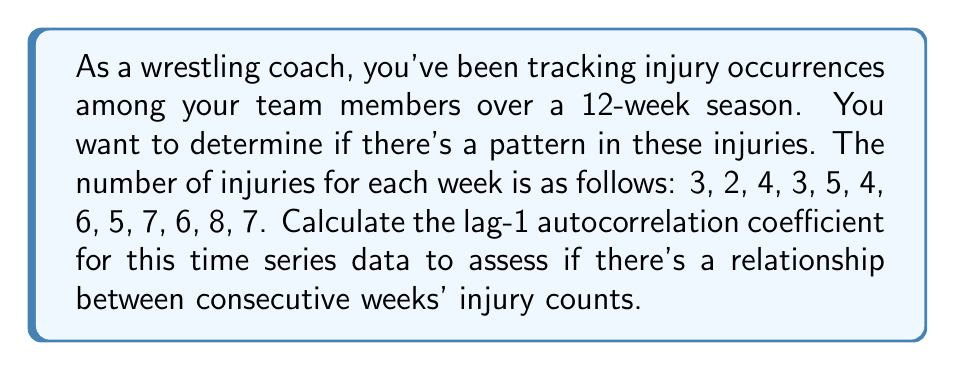Can you answer this question? To calculate the lag-1 autocorrelation coefficient, we'll follow these steps:

1) First, calculate the mean of the series:
   $$\bar{x} = \frac{3 + 2 + 4 + 3 + 5 + 4 + 6 + 5 + 7 + 6 + 8 + 7}{12} = 5$$

2) Calculate the numerator of the autocorrelation formula:
   $$\sum_{t=2}^{12} (x_t - \bar{x})(x_{t-1} - \bar{x})$$
   
   $(2-5)(3-5) + (4-5)(2-5) + (3-5)(4-5) + (5-5)(3-5) + (4-5)(5-5) +$
   $(6-5)(4-5) + (5-5)(6-5) + (7-5)(5-5) + (6-5)(7-5) + (8-5)(6-5) + (7-5)(8-5)$
   
   $= 4 + (-3) + (-1) + 0 + 0 + 1 + 0 + 0 + 1 + 3 + 6 = 11$

3) Calculate the denominator:
   $$\sum_{t=1}^{12} (x_t - \bar{x})^2$$
   
   $(3-5)^2 + (2-5)^2 + (4-5)^2 + (3-5)^2 + (5-5)^2 + (4-5)^2 +$
   $(6-5)^2 + (5-5)^2 + (7-5)^2 + (6-5)^2 + (8-5)^2 + (7-5)^2$
   
   $= 4 + 9 + 1 + 4 + 0 + 1 + 1 + 0 + 4 + 1 + 9 + 4 = 38$

4) The lag-1 autocorrelation coefficient is:
   $$r_1 = \frac{11}{38} \approx 0.2895$$

This positive autocorrelation suggests a tendency for high injury counts to be followed by high counts, and low counts by low counts, indicating a possible pattern in injury occurrences over the season.
Answer: The lag-1 autocorrelation coefficient is approximately 0.2895. 